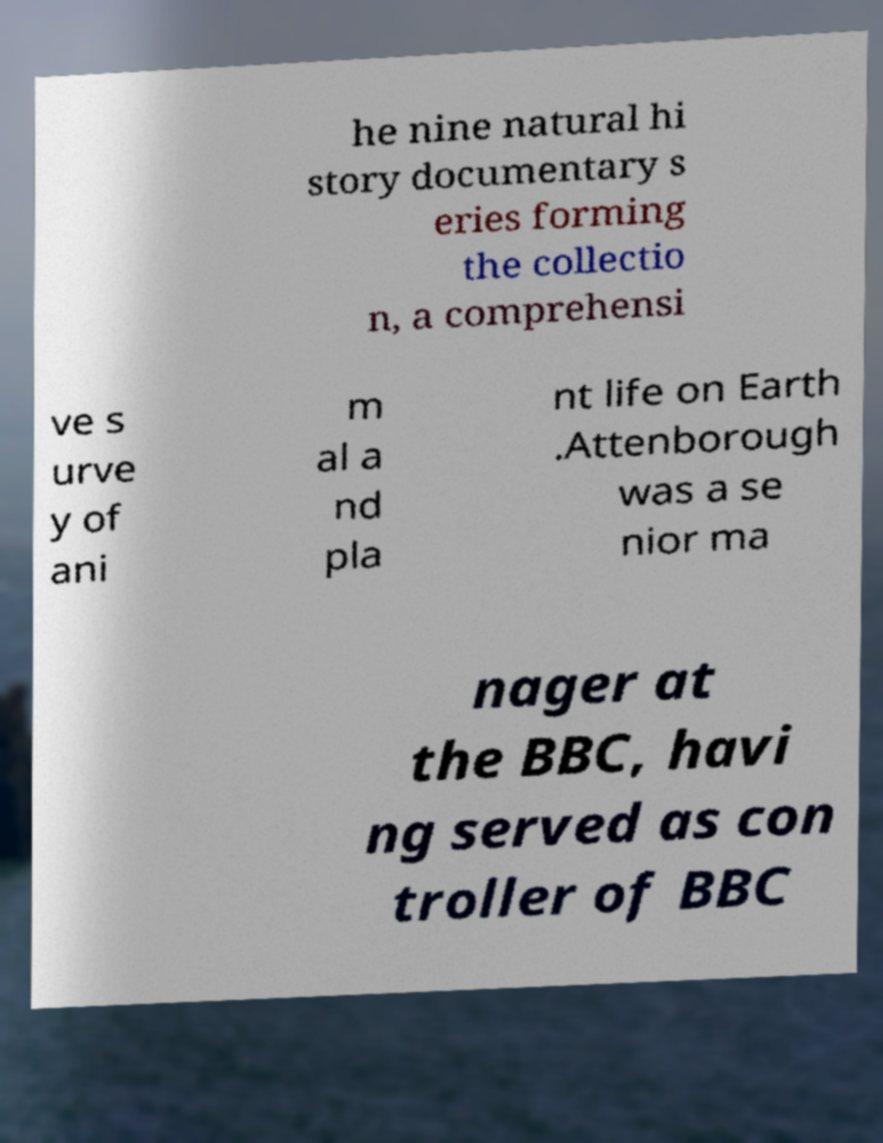Could you assist in decoding the text presented in this image and type it out clearly? he nine natural hi story documentary s eries forming the collectio n, a comprehensi ve s urve y of ani m al a nd pla nt life on Earth .Attenborough was a se nior ma nager at the BBC, havi ng served as con troller of BBC 